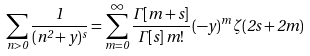Convert formula to latex. <formula><loc_0><loc_0><loc_500><loc_500>\sum _ { n > 0 } \frac { 1 } { ( n ^ { 2 } + y ) ^ { s } } = \sum _ { m = 0 } ^ { \infty } \frac { \Gamma [ m + s ] } { \Gamma [ s ] \, m ! } \, ( { - y } ) ^ { m } \, \zeta ( 2 s + 2 m )</formula> 